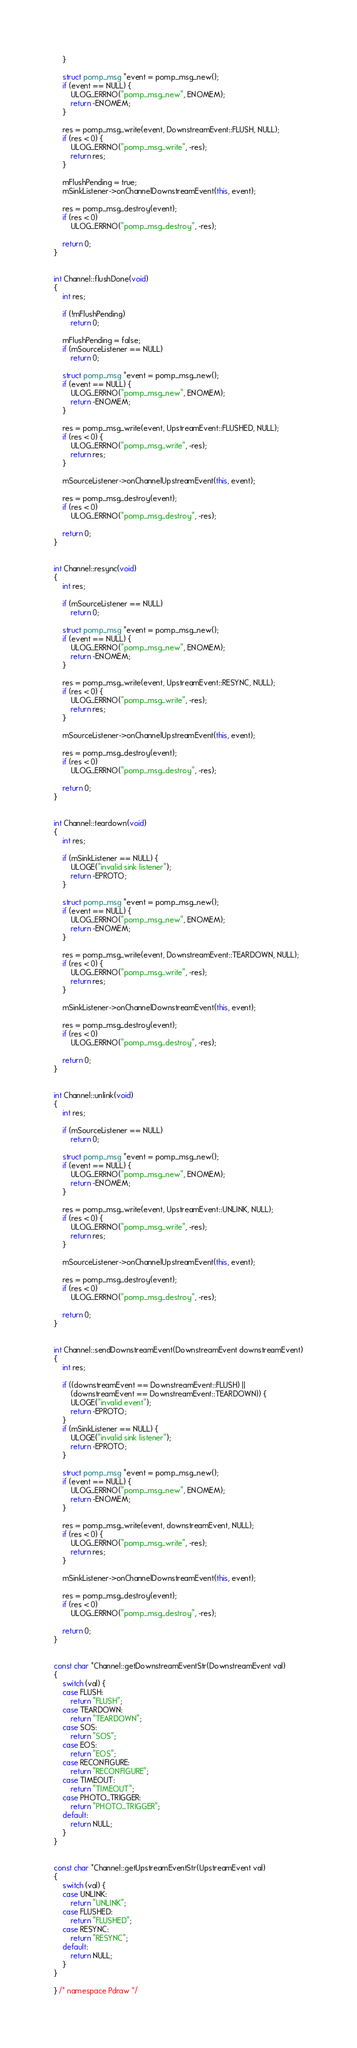<code> <loc_0><loc_0><loc_500><loc_500><_C++_>	}

	struct pomp_msg *event = pomp_msg_new();
	if (event == NULL) {
		ULOG_ERRNO("pomp_msg_new", ENOMEM);
		return -ENOMEM;
	}

	res = pomp_msg_write(event, DownstreamEvent::FLUSH, NULL);
	if (res < 0) {
		ULOG_ERRNO("pomp_msg_write", -res);
		return res;
	}

	mFlushPending = true;
	mSinkListener->onChannelDownstreamEvent(this, event);

	res = pomp_msg_destroy(event);
	if (res < 0)
		ULOG_ERRNO("pomp_msg_destroy", -res);

	return 0;
}


int Channel::flushDone(void)
{
	int res;

	if (!mFlushPending)
		return 0;

	mFlushPending = false;
	if (mSourceListener == NULL)
		return 0;

	struct pomp_msg *event = pomp_msg_new();
	if (event == NULL) {
		ULOG_ERRNO("pomp_msg_new", ENOMEM);
		return -ENOMEM;
	}

	res = pomp_msg_write(event, UpstreamEvent::FLUSHED, NULL);
	if (res < 0) {
		ULOG_ERRNO("pomp_msg_write", -res);
		return res;
	}

	mSourceListener->onChannelUpstreamEvent(this, event);

	res = pomp_msg_destroy(event);
	if (res < 0)
		ULOG_ERRNO("pomp_msg_destroy", -res);

	return 0;
}


int Channel::resync(void)
{
	int res;

	if (mSourceListener == NULL)
		return 0;

	struct pomp_msg *event = pomp_msg_new();
	if (event == NULL) {
		ULOG_ERRNO("pomp_msg_new", ENOMEM);
		return -ENOMEM;
	}

	res = pomp_msg_write(event, UpstreamEvent::RESYNC, NULL);
	if (res < 0) {
		ULOG_ERRNO("pomp_msg_write", -res);
		return res;
	}

	mSourceListener->onChannelUpstreamEvent(this, event);

	res = pomp_msg_destroy(event);
	if (res < 0)
		ULOG_ERRNO("pomp_msg_destroy", -res);

	return 0;
}


int Channel::teardown(void)
{
	int res;

	if (mSinkListener == NULL) {
		ULOGE("invalid sink listener");
		return -EPROTO;
	}

	struct pomp_msg *event = pomp_msg_new();
	if (event == NULL) {
		ULOG_ERRNO("pomp_msg_new", ENOMEM);
		return -ENOMEM;
	}

	res = pomp_msg_write(event, DownstreamEvent::TEARDOWN, NULL);
	if (res < 0) {
		ULOG_ERRNO("pomp_msg_write", -res);
		return res;
	}

	mSinkListener->onChannelDownstreamEvent(this, event);

	res = pomp_msg_destroy(event);
	if (res < 0)
		ULOG_ERRNO("pomp_msg_destroy", -res);

	return 0;
}


int Channel::unlink(void)
{
	int res;

	if (mSourceListener == NULL)
		return 0;

	struct pomp_msg *event = pomp_msg_new();
	if (event == NULL) {
		ULOG_ERRNO("pomp_msg_new", ENOMEM);
		return -ENOMEM;
	}

	res = pomp_msg_write(event, UpstreamEvent::UNLINK, NULL);
	if (res < 0) {
		ULOG_ERRNO("pomp_msg_write", -res);
		return res;
	}

	mSourceListener->onChannelUpstreamEvent(this, event);

	res = pomp_msg_destroy(event);
	if (res < 0)
		ULOG_ERRNO("pomp_msg_destroy", -res);

	return 0;
}


int Channel::sendDownstreamEvent(DownstreamEvent downstreamEvent)
{
	int res;

	if ((downstreamEvent == DownstreamEvent::FLUSH) ||
	    (downstreamEvent == DownstreamEvent::TEARDOWN)) {
		ULOGE("invalid event");
		return -EPROTO;
	}
	if (mSinkListener == NULL) {
		ULOGE("invalid sink listener");
		return -EPROTO;
	}

	struct pomp_msg *event = pomp_msg_new();
	if (event == NULL) {
		ULOG_ERRNO("pomp_msg_new", ENOMEM);
		return -ENOMEM;
	}

	res = pomp_msg_write(event, downstreamEvent, NULL);
	if (res < 0) {
		ULOG_ERRNO("pomp_msg_write", -res);
		return res;
	}

	mSinkListener->onChannelDownstreamEvent(this, event);

	res = pomp_msg_destroy(event);
	if (res < 0)
		ULOG_ERRNO("pomp_msg_destroy", -res);

	return 0;
}


const char *Channel::getDownstreamEventStr(DownstreamEvent val)
{
	switch (val) {
	case FLUSH:
		return "FLUSH";
	case TEARDOWN:
		return "TEARDOWN";
	case SOS:
		return "SOS";
	case EOS:
		return "EOS";
	case RECONFIGURE:
		return "RECONFIGURE";
	case TIMEOUT:
		return "TIMEOUT";
	case PHOTO_TRIGGER:
		return "PHOTO_TRIGGER";
	default:
		return NULL;
	}
}


const char *Channel::getUpstreamEventStr(UpstreamEvent val)
{
	switch (val) {
	case UNLINK:
		return "UNLINK";
	case FLUSHED:
		return "FLUSHED";
	case RESYNC:
		return "RESYNC";
	default:
		return NULL;
	}
}

} /* namespace Pdraw */
</code> 